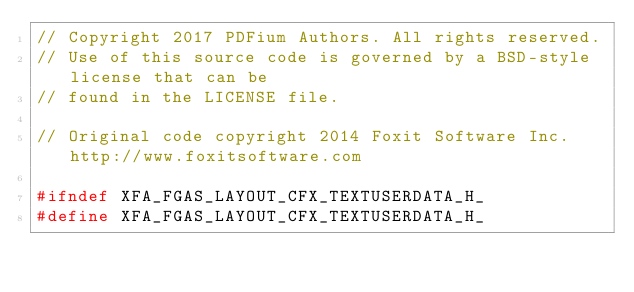Convert code to text. <code><loc_0><loc_0><loc_500><loc_500><_C_>// Copyright 2017 PDFium Authors. All rights reserved.
// Use of this source code is governed by a BSD-style license that can be
// found in the LICENSE file.

// Original code copyright 2014 Foxit Software Inc. http://www.foxitsoftware.com

#ifndef XFA_FGAS_LAYOUT_CFX_TEXTUSERDATA_H_
#define XFA_FGAS_LAYOUT_CFX_TEXTUSERDATA_H_
</code> 